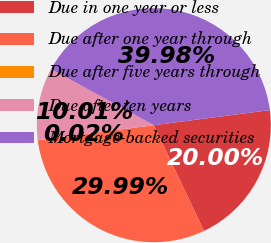<chart> <loc_0><loc_0><loc_500><loc_500><pie_chart><fcel>Due in one year or less<fcel>Due after one year through<fcel>Due after five years through<fcel>Due after ten years<fcel>Mortgage-backed securities<nl><fcel>20.0%<fcel>29.99%<fcel>0.02%<fcel>10.01%<fcel>39.98%<nl></chart> 